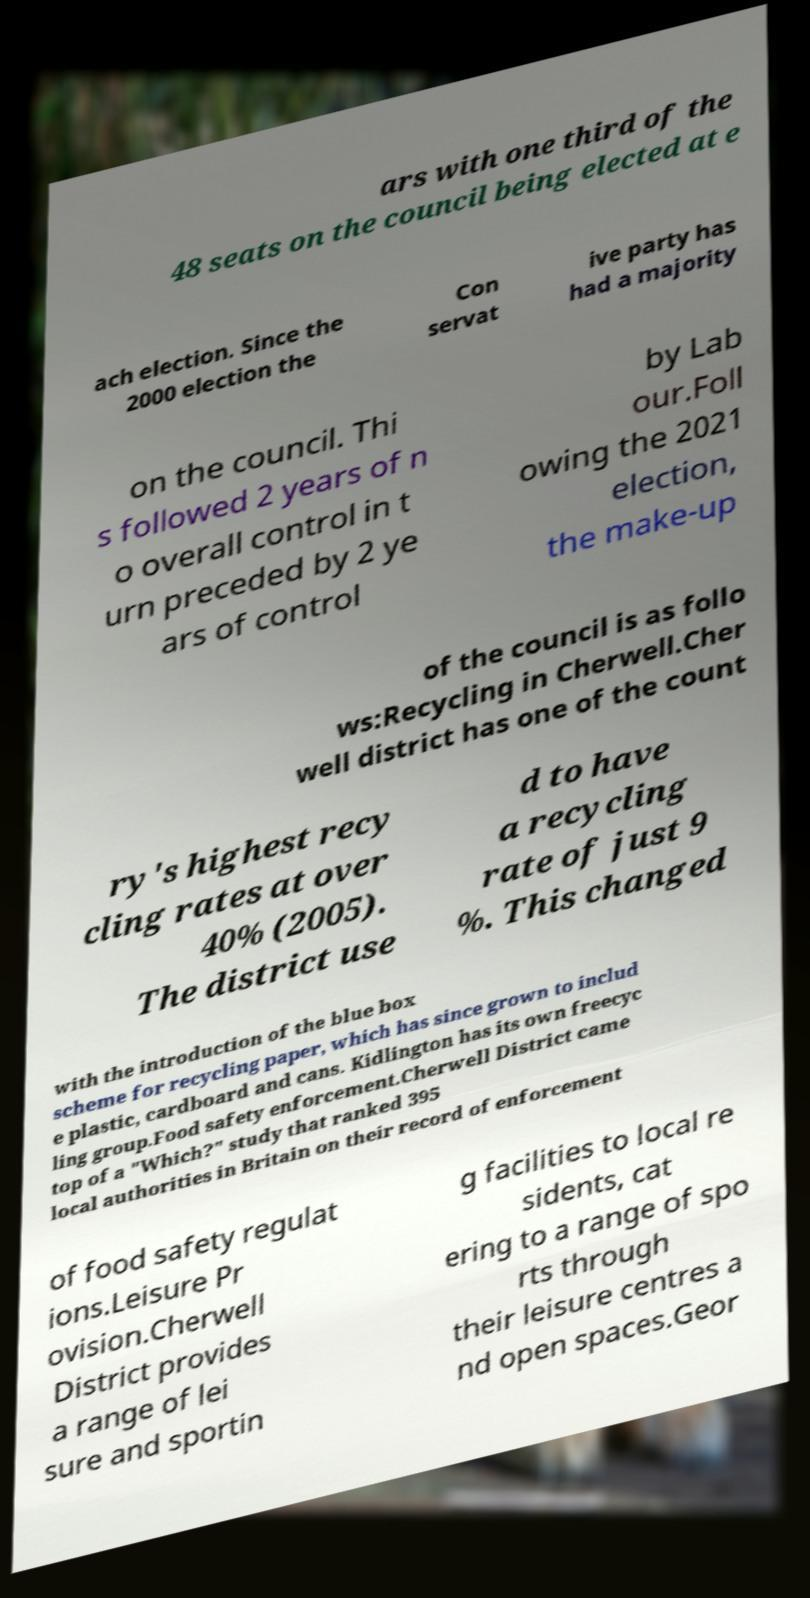Can you read and provide the text displayed in the image?This photo seems to have some interesting text. Can you extract and type it out for me? ars with one third of the 48 seats on the council being elected at e ach election. Since the 2000 election the Con servat ive party has had a majority on the council. Thi s followed 2 years of n o overall control in t urn preceded by 2 ye ars of control by Lab our.Foll owing the 2021 election, the make-up of the council is as follo ws:Recycling in Cherwell.Cher well district has one of the count ry's highest recy cling rates at over 40% (2005). The district use d to have a recycling rate of just 9 %. This changed with the introduction of the blue box scheme for recycling paper, which has since grown to includ e plastic, cardboard and cans. Kidlington has its own freecyc ling group.Food safety enforcement.Cherwell District came top of a "Which?" study that ranked 395 local authorities in Britain on their record of enforcement of food safety regulat ions.Leisure Pr ovision.Cherwell District provides a range of lei sure and sportin g facilities to local re sidents, cat ering to a range of spo rts through their leisure centres a nd open spaces.Geor 